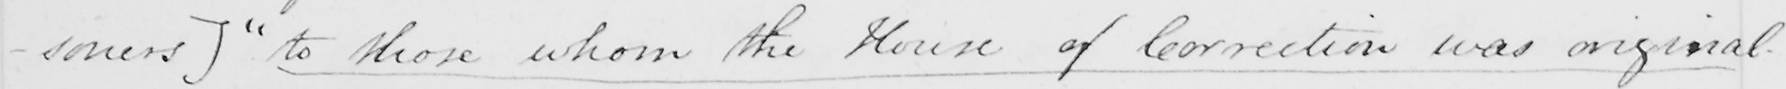Please provide the text content of this handwritten line. -soners ]   " to those whom the House of Correction was originally 